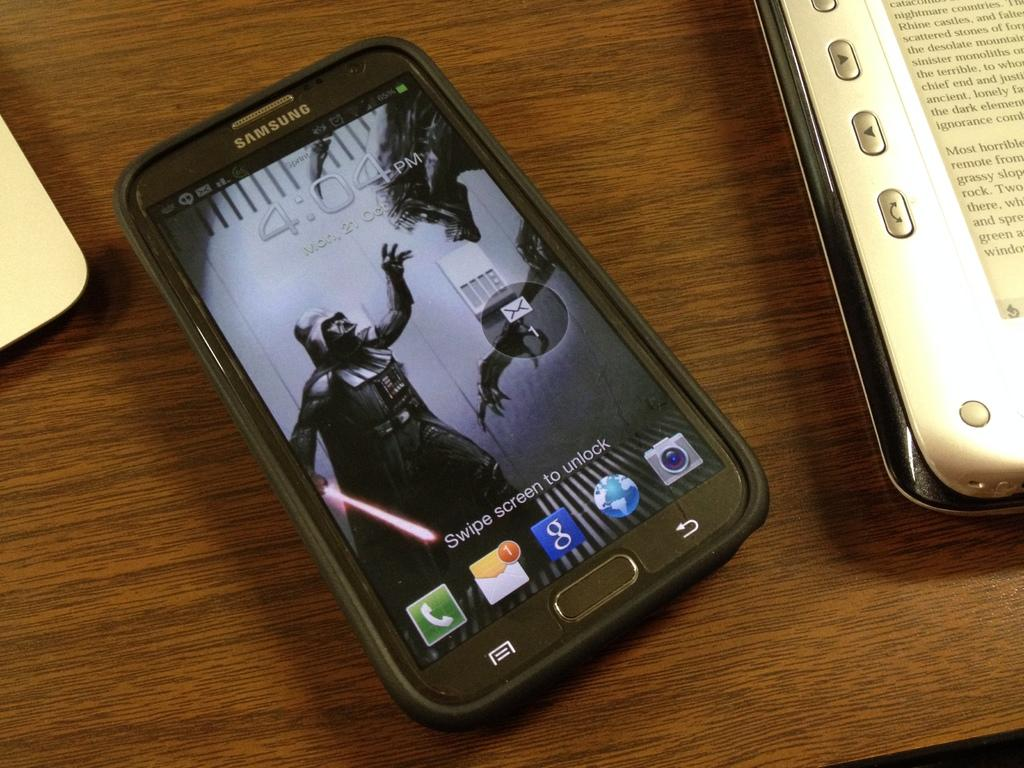<image>
Describe the image concisely. A samsung phone that has the time 4:04 pm. 